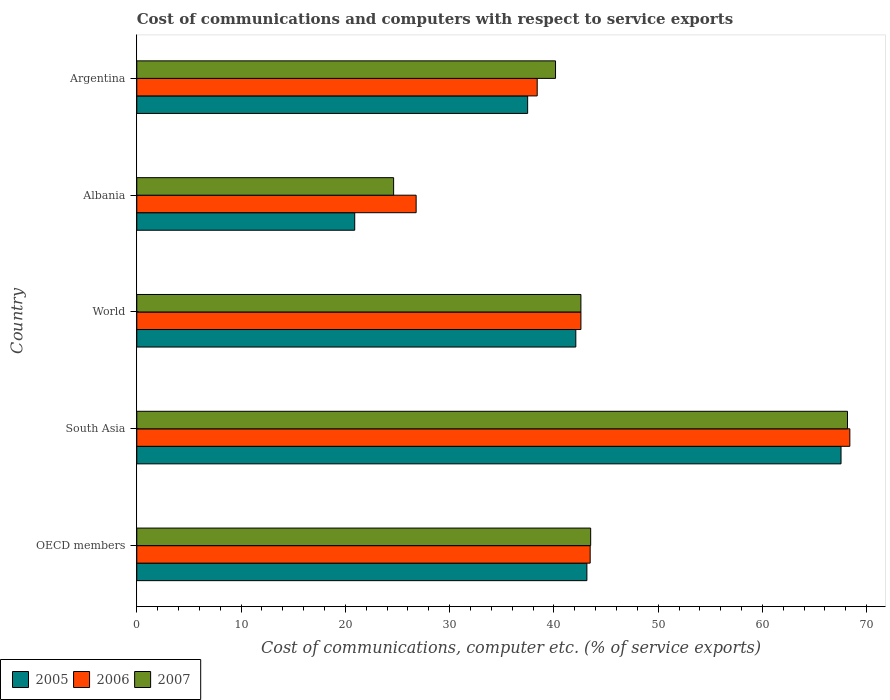How many different coloured bars are there?
Offer a very short reply. 3. How many bars are there on the 5th tick from the bottom?
Keep it short and to the point. 3. What is the label of the 2nd group of bars from the top?
Your answer should be very brief. Albania. What is the cost of communications and computers in 2006 in Albania?
Offer a very short reply. 26.79. Across all countries, what is the maximum cost of communications and computers in 2006?
Your answer should be very brief. 68.39. Across all countries, what is the minimum cost of communications and computers in 2007?
Offer a very short reply. 24.63. In which country was the cost of communications and computers in 2006 minimum?
Your response must be concise. Albania. What is the total cost of communications and computers in 2005 in the graph?
Make the answer very short. 211.2. What is the difference between the cost of communications and computers in 2007 in Albania and that in Argentina?
Make the answer very short. -15.53. What is the difference between the cost of communications and computers in 2007 in Argentina and the cost of communications and computers in 2005 in South Asia?
Give a very brief answer. -27.38. What is the average cost of communications and computers in 2006 per country?
Offer a very short reply. 43.93. What is the difference between the cost of communications and computers in 2005 and cost of communications and computers in 2007 in World?
Give a very brief answer. -0.49. What is the ratio of the cost of communications and computers in 2007 in OECD members to that in World?
Offer a very short reply. 1.02. Is the difference between the cost of communications and computers in 2005 in OECD members and South Asia greater than the difference between the cost of communications and computers in 2007 in OECD members and South Asia?
Make the answer very short. Yes. What is the difference between the highest and the second highest cost of communications and computers in 2005?
Ensure brevity in your answer.  24.37. What is the difference between the highest and the lowest cost of communications and computers in 2005?
Ensure brevity in your answer.  46.64. What does the 1st bar from the bottom in OECD members represents?
Your response must be concise. 2005. How many bars are there?
Provide a succinct answer. 15. Are all the bars in the graph horizontal?
Your response must be concise. Yes. What is the difference between two consecutive major ticks on the X-axis?
Make the answer very short. 10. Are the values on the major ticks of X-axis written in scientific E-notation?
Your answer should be very brief. No. Does the graph contain any zero values?
Your answer should be very brief. No. Does the graph contain grids?
Your answer should be compact. No. How many legend labels are there?
Offer a terse response. 3. What is the title of the graph?
Your answer should be very brief. Cost of communications and computers with respect to service exports. What is the label or title of the X-axis?
Your answer should be very brief. Cost of communications, computer etc. (% of service exports). What is the label or title of the Y-axis?
Your answer should be compact. Country. What is the Cost of communications, computer etc. (% of service exports) of 2005 in OECD members?
Provide a short and direct response. 43.17. What is the Cost of communications, computer etc. (% of service exports) in 2006 in OECD members?
Keep it short and to the point. 43.48. What is the Cost of communications, computer etc. (% of service exports) in 2007 in OECD members?
Offer a very short reply. 43.53. What is the Cost of communications, computer etc. (% of service exports) in 2005 in South Asia?
Ensure brevity in your answer.  67.54. What is the Cost of communications, computer etc. (% of service exports) in 2006 in South Asia?
Offer a terse response. 68.39. What is the Cost of communications, computer etc. (% of service exports) of 2007 in South Asia?
Offer a terse response. 68.16. What is the Cost of communications, computer etc. (% of service exports) of 2005 in World?
Your answer should be very brief. 42.1. What is the Cost of communications, computer etc. (% of service exports) in 2006 in World?
Your answer should be very brief. 42.59. What is the Cost of communications, computer etc. (% of service exports) in 2007 in World?
Ensure brevity in your answer.  42.59. What is the Cost of communications, computer etc. (% of service exports) of 2005 in Albania?
Your response must be concise. 20.9. What is the Cost of communications, computer etc. (% of service exports) in 2006 in Albania?
Make the answer very short. 26.79. What is the Cost of communications, computer etc. (% of service exports) of 2007 in Albania?
Offer a very short reply. 24.63. What is the Cost of communications, computer etc. (% of service exports) in 2005 in Argentina?
Provide a succinct answer. 37.49. What is the Cost of communications, computer etc. (% of service exports) of 2006 in Argentina?
Offer a very short reply. 38.4. What is the Cost of communications, computer etc. (% of service exports) in 2007 in Argentina?
Offer a very short reply. 40.16. Across all countries, what is the maximum Cost of communications, computer etc. (% of service exports) of 2005?
Ensure brevity in your answer.  67.54. Across all countries, what is the maximum Cost of communications, computer etc. (% of service exports) of 2006?
Your response must be concise. 68.39. Across all countries, what is the maximum Cost of communications, computer etc. (% of service exports) of 2007?
Provide a succinct answer. 68.16. Across all countries, what is the minimum Cost of communications, computer etc. (% of service exports) of 2005?
Provide a succinct answer. 20.9. Across all countries, what is the minimum Cost of communications, computer etc. (% of service exports) of 2006?
Provide a succinct answer. 26.79. Across all countries, what is the minimum Cost of communications, computer etc. (% of service exports) in 2007?
Keep it short and to the point. 24.63. What is the total Cost of communications, computer etc. (% of service exports) in 2005 in the graph?
Offer a very short reply. 211.2. What is the total Cost of communications, computer etc. (% of service exports) in 2006 in the graph?
Your response must be concise. 219.65. What is the total Cost of communications, computer etc. (% of service exports) in 2007 in the graph?
Offer a very short reply. 219.07. What is the difference between the Cost of communications, computer etc. (% of service exports) in 2005 in OECD members and that in South Asia?
Keep it short and to the point. -24.37. What is the difference between the Cost of communications, computer etc. (% of service exports) in 2006 in OECD members and that in South Asia?
Your response must be concise. -24.9. What is the difference between the Cost of communications, computer etc. (% of service exports) in 2007 in OECD members and that in South Asia?
Your response must be concise. -24.63. What is the difference between the Cost of communications, computer etc. (% of service exports) of 2005 in OECD members and that in World?
Your response must be concise. 1.06. What is the difference between the Cost of communications, computer etc. (% of service exports) in 2006 in OECD members and that in World?
Provide a short and direct response. 0.89. What is the difference between the Cost of communications, computer etc. (% of service exports) in 2007 in OECD members and that in World?
Your response must be concise. 0.94. What is the difference between the Cost of communications, computer etc. (% of service exports) in 2005 in OECD members and that in Albania?
Offer a very short reply. 22.27. What is the difference between the Cost of communications, computer etc. (% of service exports) in 2006 in OECD members and that in Albania?
Provide a succinct answer. 16.69. What is the difference between the Cost of communications, computer etc. (% of service exports) in 2007 in OECD members and that in Albania?
Offer a terse response. 18.9. What is the difference between the Cost of communications, computer etc. (% of service exports) of 2005 in OECD members and that in Argentina?
Your answer should be compact. 5.68. What is the difference between the Cost of communications, computer etc. (% of service exports) in 2006 in OECD members and that in Argentina?
Keep it short and to the point. 5.08. What is the difference between the Cost of communications, computer etc. (% of service exports) in 2007 in OECD members and that in Argentina?
Your answer should be very brief. 3.37. What is the difference between the Cost of communications, computer etc. (% of service exports) in 2005 in South Asia and that in World?
Give a very brief answer. 25.44. What is the difference between the Cost of communications, computer etc. (% of service exports) in 2006 in South Asia and that in World?
Offer a very short reply. 25.79. What is the difference between the Cost of communications, computer etc. (% of service exports) of 2007 in South Asia and that in World?
Offer a very short reply. 25.57. What is the difference between the Cost of communications, computer etc. (% of service exports) of 2005 in South Asia and that in Albania?
Keep it short and to the point. 46.64. What is the difference between the Cost of communications, computer etc. (% of service exports) of 2006 in South Asia and that in Albania?
Offer a terse response. 41.59. What is the difference between the Cost of communications, computer etc. (% of service exports) in 2007 in South Asia and that in Albania?
Offer a terse response. 43.53. What is the difference between the Cost of communications, computer etc. (% of service exports) in 2005 in South Asia and that in Argentina?
Offer a very short reply. 30.06. What is the difference between the Cost of communications, computer etc. (% of service exports) of 2006 in South Asia and that in Argentina?
Keep it short and to the point. 29.98. What is the difference between the Cost of communications, computer etc. (% of service exports) in 2007 in South Asia and that in Argentina?
Provide a succinct answer. 28. What is the difference between the Cost of communications, computer etc. (% of service exports) in 2005 in World and that in Albania?
Your response must be concise. 21.2. What is the difference between the Cost of communications, computer etc. (% of service exports) of 2006 in World and that in Albania?
Give a very brief answer. 15.8. What is the difference between the Cost of communications, computer etc. (% of service exports) of 2007 in World and that in Albania?
Your response must be concise. 17.96. What is the difference between the Cost of communications, computer etc. (% of service exports) of 2005 in World and that in Argentina?
Offer a terse response. 4.62. What is the difference between the Cost of communications, computer etc. (% of service exports) of 2006 in World and that in Argentina?
Make the answer very short. 4.19. What is the difference between the Cost of communications, computer etc. (% of service exports) in 2007 in World and that in Argentina?
Ensure brevity in your answer.  2.43. What is the difference between the Cost of communications, computer etc. (% of service exports) in 2005 in Albania and that in Argentina?
Make the answer very short. -16.59. What is the difference between the Cost of communications, computer etc. (% of service exports) in 2006 in Albania and that in Argentina?
Your answer should be compact. -11.61. What is the difference between the Cost of communications, computer etc. (% of service exports) of 2007 in Albania and that in Argentina?
Offer a terse response. -15.53. What is the difference between the Cost of communications, computer etc. (% of service exports) of 2005 in OECD members and the Cost of communications, computer etc. (% of service exports) of 2006 in South Asia?
Keep it short and to the point. -25.22. What is the difference between the Cost of communications, computer etc. (% of service exports) in 2005 in OECD members and the Cost of communications, computer etc. (% of service exports) in 2007 in South Asia?
Keep it short and to the point. -24.99. What is the difference between the Cost of communications, computer etc. (% of service exports) of 2006 in OECD members and the Cost of communications, computer etc. (% of service exports) of 2007 in South Asia?
Offer a terse response. -24.68. What is the difference between the Cost of communications, computer etc. (% of service exports) of 2005 in OECD members and the Cost of communications, computer etc. (% of service exports) of 2006 in World?
Your response must be concise. 0.57. What is the difference between the Cost of communications, computer etc. (% of service exports) in 2005 in OECD members and the Cost of communications, computer etc. (% of service exports) in 2007 in World?
Provide a succinct answer. 0.57. What is the difference between the Cost of communications, computer etc. (% of service exports) of 2006 in OECD members and the Cost of communications, computer etc. (% of service exports) of 2007 in World?
Make the answer very short. 0.89. What is the difference between the Cost of communications, computer etc. (% of service exports) in 2005 in OECD members and the Cost of communications, computer etc. (% of service exports) in 2006 in Albania?
Your response must be concise. 16.38. What is the difference between the Cost of communications, computer etc. (% of service exports) in 2005 in OECD members and the Cost of communications, computer etc. (% of service exports) in 2007 in Albania?
Make the answer very short. 18.53. What is the difference between the Cost of communications, computer etc. (% of service exports) of 2006 in OECD members and the Cost of communications, computer etc. (% of service exports) of 2007 in Albania?
Your response must be concise. 18.85. What is the difference between the Cost of communications, computer etc. (% of service exports) of 2005 in OECD members and the Cost of communications, computer etc. (% of service exports) of 2006 in Argentina?
Make the answer very short. 4.76. What is the difference between the Cost of communications, computer etc. (% of service exports) in 2005 in OECD members and the Cost of communications, computer etc. (% of service exports) in 2007 in Argentina?
Keep it short and to the point. 3.01. What is the difference between the Cost of communications, computer etc. (% of service exports) of 2006 in OECD members and the Cost of communications, computer etc. (% of service exports) of 2007 in Argentina?
Keep it short and to the point. 3.32. What is the difference between the Cost of communications, computer etc. (% of service exports) of 2005 in South Asia and the Cost of communications, computer etc. (% of service exports) of 2006 in World?
Your response must be concise. 24.95. What is the difference between the Cost of communications, computer etc. (% of service exports) in 2005 in South Asia and the Cost of communications, computer etc. (% of service exports) in 2007 in World?
Make the answer very short. 24.95. What is the difference between the Cost of communications, computer etc. (% of service exports) of 2006 in South Asia and the Cost of communications, computer etc. (% of service exports) of 2007 in World?
Your answer should be very brief. 25.79. What is the difference between the Cost of communications, computer etc. (% of service exports) in 2005 in South Asia and the Cost of communications, computer etc. (% of service exports) in 2006 in Albania?
Make the answer very short. 40.75. What is the difference between the Cost of communications, computer etc. (% of service exports) in 2005 in South Asia and the Cost of communications, computer etc. (% of service exports) in 2007 in Albania?
Provide a succinct answer. 42.91. What is the difference between the Cost of communications, computer etc. (% of service exports) of 2006 in South Asia and the Cost of communications, computer etc. (% of service exports) of 2007 in Albania?
Offer a terse response. 43.75. What is the difference between the Cost of communications, computer etc. (% of service exports) of 2005 in South Asia and the Cost of communications, computer etc. (% of service exports) of 2006 in Argentina?
Your response must be concise. 29.14. What is the difference between the Cost of communications, computer etc. (% of service exports) in 2005 in South Asia and the Cost of communications, computer etc. (% of service exports) in 2007 in Argentina?
Your answer should be very brief. 27.38. What is the difference between the Cost of communications, computer etc. (% of service exports) of 2006 in South Asia and the Cost of communications, computer etc. (% of service exports) of 2007 in Argentina?
Your answer should be very brief. 28.23. What is the difference between the Cost of communications, computer etc. (% of service exports) in 2005 in World and the Cost of communications, computer etc. (% of service exports) in 2006 in Albania?
Ensure brevity in your answer.  15.31. What is the difference between the Cost of communications, computer etc. (% of service exports) of 2005 in World and the Cost of communications, computer etc. (% of service exports) of 2007 in Albania?
Your answer should be compact. 17.47. What is the difference between the Cost of communications, computer etc. (% of service exports) in 2006 in World and the Cost of communications, computer etc. (% of service exports) in 2007 in Albania?
Your answer should be very brief. 17.96. What is the difference between the Cost of communications, computer etc. (% of service exports) in 2005 in World and the Cost of communications, computer etc. (% of service exports) in 2006 in Argentina?
Give a very brief answer. 3.7. What is the difference between the Cost of communications, computer etc. (% of service exports) in 2005 in World and the Cost of communications, computer etc. (% of service exports) in 2007 in Argentina?
Ensure brevity in your answer.  1.95. What is the difference between the Cost of communications, computer etc. (% of service exports) in 2006 in World and the Cost of communications, computer etc. (% of service exports) in 2007 in Argentina?
Keep it short and to the point. 2.44. What is the difference between the Cost of communications, computer etc. (% of service exports) of 2005 in Albania and the Cost of communications, computer etc. (% of service exports) of 2006 in Argentina?
Keep it short and to the point. -17.5. What is the difference between the Cost of communications, computer etc. (% of service exports) in 2005 in Albania and the Cost of communications, computer etc. (% of service exports) in 2007 in Argentina?
Your answer should be very brief. -19.26. What is the difference between the Cost of communications, computer etc. (% of service exports) of 2006 in Albania and the Cost of communications, computer etc. (% of service exports) of 2007 in Argentina?
Offer a very short reply. -13.37. What is the average Cost of communications, computer etc. (% of service exports) in 2005 per country?
Keep it short and to the point. 42.24. What is the average Cost of communications, computer etc. (% of service exports) of 2006 per country?
Give a very brief answer. 43.93. What is the average Cost of communications, computer etc. (% of service exports) of 2007 per country?
Offer a terse response. 43.81. What is the difference between the Cost of communications, computer etc. (% of service exports) of 2005 and Cost of communications, computer etc. (% of service exports) of 2006 in OECD members?
Provide a succinct answer. -0.32. What is the difference between the Cost of communications, computer etc. (% of service exports) of 2005 and Cost of communications, computer etc. (% of service exports) of 2007 in OECD members?
Your answer should be compact. -0.36. What is the difference between the Cost of communications, computer etc. (% of service exports) of 2006 and Cost of communications, computer etc. (% of service exports) of 2007 in OECD members?
Ensure brevity in your answer.  -0.05. What is the difference between the Cost of communications, computer etc. (% of service exports) in 2005 and Cost of communications, computer etc. (% of service exports) in 2006 in South Asia?
Give a very brief answer. -0.84. What is the difference between the Cost of communications, computer etc. (% of service exports) of 2005 and Cost of communications, computer etc. (% of service exports) of 2007 in South Asia?
Offer a very short reply. -0.62. What is the difference between the Cost of communications, computer etc. (% of service exports) of 2006 and Cost of communications, computer etc. (% of service exports) of 2007 in South Asia?
Provide a succinct answer. 0.22. What is the difference between the Cost of communications, computer etc. (% of service exports) of 2005 and Cost of communications, computer etc. (% of service exports) of 2006 in World?
Provide a succinct answer. -0.49. What is the difference between the Cost of communications, computer etc. (% of service exports) in 2005 and Cost of communications, computer etc. (% of service exports) in 2007 in World?
Offer a terse response. -0.49. What is the difference between the Cost of communications, computer etc. (% of service exports) of 2006 and Cost of communications, computer etc. (% of service exports) of 2007 in World?
Give a very brief answer. 0. What is the difference between the Cost of communications, computer etc. (% of service exports) in 2005 and Cost of communications, computer etc. (% of service exports) in 2006 in Albania?
Your answer should be compact. -5.89. What is the difference between the Cost of communications, computer etc. (% of service exports) in 2005 and Cost of communications, computer etc. (% of service exports) in 2007 in Albania?
Offer a terse response. -3.73. What is the difference between the Cost of communications, computer etc. (% of service exports) in 2006 and Cost of communications, computer etc. (% of service exports) in 2007 in Albania?
Give a very brief answer. 2.16. What is the difference between the Cost of communications, computer etc. (% of service exports) of 2005 and Cost of communications, computer etc. (% of service exports) of 2006 in Argentina?
Offer a very short reply. -0.92. What is the difference between the Cost of communications, computer etc. (% of service exports) in 2005 and Cost of communications, computer etc. (% of service exports) in 2007 in Argentina?
Your answer should be very brief. -2.67. What is the difference between the Cost of communications, computer etc. (% of service exports) in 2006 and Cost of communications, computer etc. (% of service exports) in 2007 in Argentina?
Provide a short and direct response. -1.76. What is the ratio of the Cost of communications, computer etc. (% of service exports) of 2005 in OECD members to that in South Asia?
Provide a short and direct response. 0.64. What is the ratio of the Cost of communications, computer etc. (% of service exports) in 2006 in OECD members to that in South Asia?
Make the answer very short. 0.64. What is the ratio of the Cost of communications, computer etc. (% of service exports) in 2007 in OECD members to that in South Asia?
Your answer should be very brief. 0.64. What is the ratio of the Cost of communications, computer etc. (% of service exports) in 2005 in OECD members to that in World?
Offer a terse response. 1.03. What is the ratio of the Cost of communications, computer etc. (% of service exports) of 2006 in OECD members to that in World?
Ensure brevity in your answer.  1.02. What is the ratio of the Cost of communications, computer etc. (% of service exports) of 2005 in OECD members to that in Albania?
Give a very brief answer. 2.07. What is the ratio of the Cost of communications, computer etc. (% of service exports) of 2006 in OECD members to that in Albania?
Offer a very short reply. 1.62. What is the ratio of the Cost of communications, computer etc. (% of service exports) of 2007 in OECD members to that in Albania?
Your answer should be compact. 1.77. What is the ratio of the Cost of communications, computer etc. (% of service exports) of 2005 in OECD members to that in Argentina?
Offer a very short reply. 1.15. What is the ratio of the Cost of communications, computer etc. (% of service exports) in 2006 in OECD members to that in Argentina?
Make the answer very short. 1.13. What is the ratio of the Cost of communications, computer etc. (% of service exports) in 2007 in OECD members to that in Argentina?
Give a very brief answer. 1.08. What is the ratio of the Cost of communications, computer etc. (% of service exports) in 2005 in South Asia to that in World?
Give a very brief answer. 1.6. What is the ratio of the Cost of communications, computer etc. (% of service exports) in 2006 in South Asia to that in World?
Keep it short and to the point. 1.61. What is the ratio of the Cost of communications, computer etc. (% of service exports) in 2007 in South Asia to that in World?
Provide a succinct answer. 1.6. What is the ratio of the Cost of communications, computer etc. (% of service exports) of 2005 in South Asia to that in Albania?
Provide a short and direct response. 3.23. What is the ratio of the Cost of communications, computer etc. (% of service exports) in 2006 in South Asia to that in Albania?
Provide a short and direct response. 2.55. What is the ratio of the Cost of communications, computer etc. (% of service exports) in 2007 in South Asia to that in Albania?
Your answer should be compact. 2.77. What is the ratio of the Cost of communications, computer etc. (% of service exports) of 2005 in South Asia to that in Argentina?
Provide a succinct answer. 1.8. What is the ratio of the Cost of communications, computer etc. (% of service exports) in 2006 in South Asia to that in Argentina?
Give a very brief answer. 1.78. What is the ratio of the Cost of communications, computer etc. (% of service exports) in 2007 in South Asia to that in Argentina?
Provide a succinct answer. 1.7. What is the ratio of the Cost of communications, computer etc. (% of service exports) in 2005 in World to that in Albania?
Ensure brevity in your answer.  2.01. What is the ratio of the Cost of communications, computer etc. (% of service exports) in 2006 in World to that in Albania?
Offer a terse response. 1.59. What is the ratio of the Cost of communications, computer etc. (% of service exports) in 2007 in World to that in Albania?
Your response must be concise. 1.73. What is the ratio of the Cost of communications, computer etc. (% of service exports) of 2005 in World to that in Argentina?
Keep it short and to the point. 1.12. What is the ratio of the Cost of communications, computer etc. (% of service exports) in 2006 in World to that in Argentina?
Make the answer very short. 1.11. What is the ratio of the Cost of communications, computer etc. (% of service exports) of 2007 in World to that in Argentina?
Your answer should be very brief. 1.06. What is the ratio of the Cost of communications, computer etc. (% of service exports) in 2005 in Albania to that in Argentina?
Provide a short and direct response. 0.56. What is the ratio of the Cost of communications, computer etc. (% of service exports) of 2006 in Albania to that in Argentina?
Provide a short and direct response. 0.7. What is the ratio of the Cost of communications, computer etc. (% of service exports) in 2007 in Albania to that in Argentina?
Keep it short and to the point. 0.61. What is the difference between the highest and the second highest Cost of communications, computer etc. (% of service exports) of 2005?
Ensure brevity in your answer.  24.37. What is the difference between the highest and the second highest Cost of communications, computer etc. (% of service exports) of 2006?
Your answer should be very brief. 24.9. What is the difference between the highest and the second highest Cost of communications, computer etc. (% of service exports) of 2007?
Give a very brief answer. 24.63. What is the difference between the highest and the lowest Cost of communications, computer etc. (% of service exports) of 2005?
Provide a short and direct response. 46.64. What is the difference between the highest and the lowest Cost of communications, computer etc. (% of service exports) in 2006?
Ensure brevity in your answer.  41.59. What is the difference between the highest and the lowest Cost of communications, computer etc. (% of service exports) in 2007?
Your answer should be very brief. 43.53. 